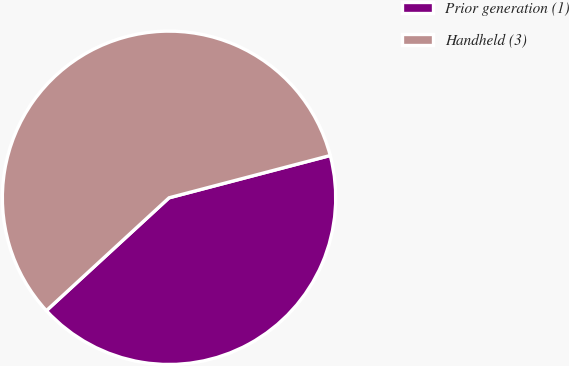<chart> <loc_0><loc_0><loc_500><loc_500><pie_chart><fcel>Prior generation (1)<fcel>Handheld (3)<nl><fcel>42.25%<fcel>57.75%<nl></chart> 